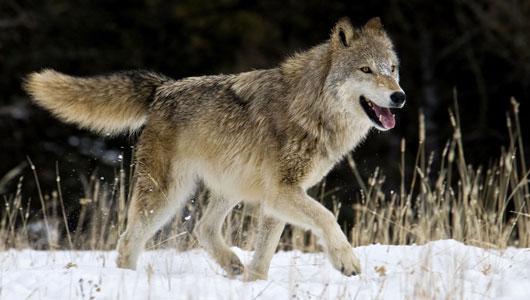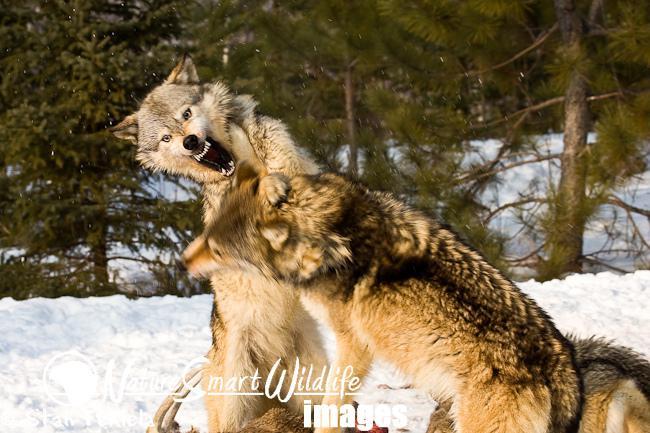The first image is the image on the left, the second image is the image on the right. Considering the images on both sides, is "Each image contains exactly two wolves who are close together, and in at least one image, the two wolves are facing off, with snarling mouths." valid? Answer yes or no. No. The first image is the image on the left, the second image is the image on the right. Examine the images to the left and right. Is the description "The left image contains exactly two wolves." accurate? Answer yes or no. No. 